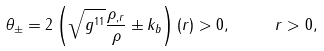Convert formula to latex. <formula><loc_0><loc_0><loc_500><loc_500>\theta _ { \pm } = 2 \left ( \sqrt { g ^ { 1 1 } } \frac { \rho _ { , r } } { \rho } \pm k _ { b } \right ) ( r ) > 0 , \text { } \text { } \text { } \text { } r > 0 ,</formula> 